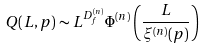<formula> <loc_0><loc_0><loc_500><loc_500>Q ( L , p ) \sim L ^ { D _ { f } ^ { ( n ) } } \Phi ^ { ( n ) } \left ( \frac { L } { \xi ^ { ( n ) } ( p ) } \right )</formula> 